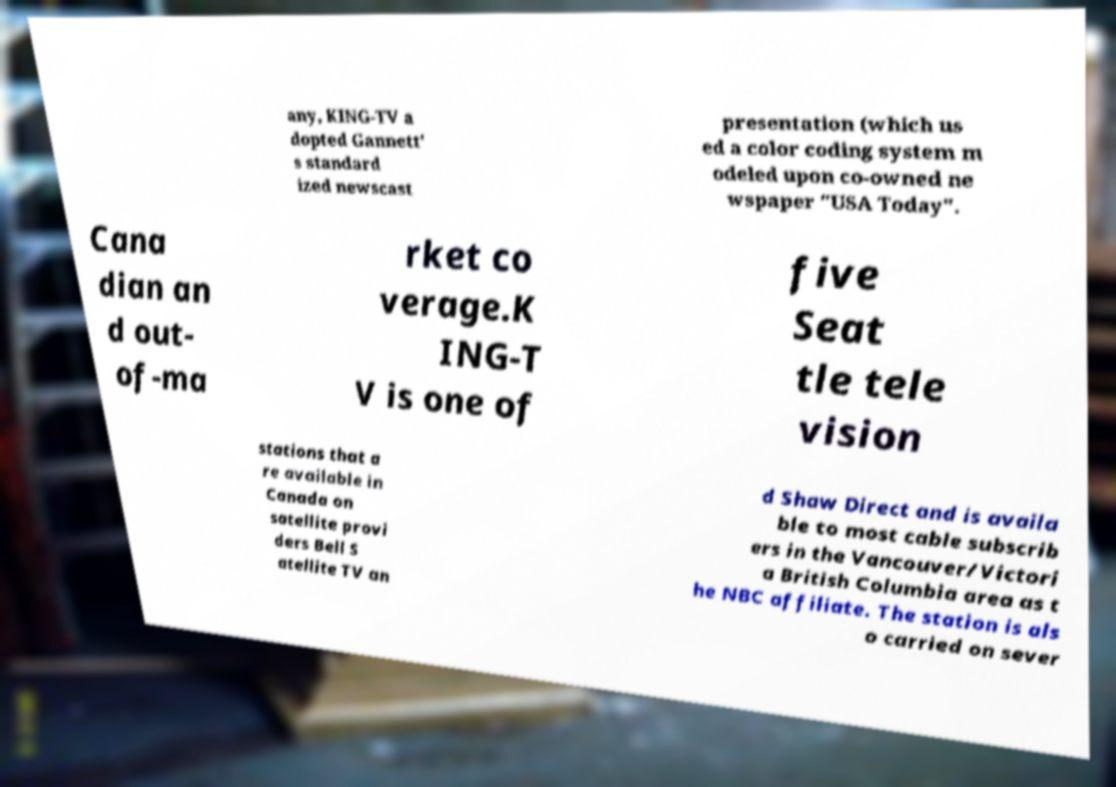Could you extract and type out the text from this image? any, KING-TV a dopted Gannett' s standard ized newscast presentation (which us ed a color coding system m odeled upon co-owned ne wspaper "USA Today". Cana dian an d out- of-ma rket co verage.K ING-T V is one of five Seat tle tele vision stations that a re available in Canada on satellite provi ders Bell S atellite TV an d Shaw Direct and is availa ble to most cable subscrib ers in the Vancouver/Victori a British Columbia area as t he NBC affiliate. The station is als o carried on sever 